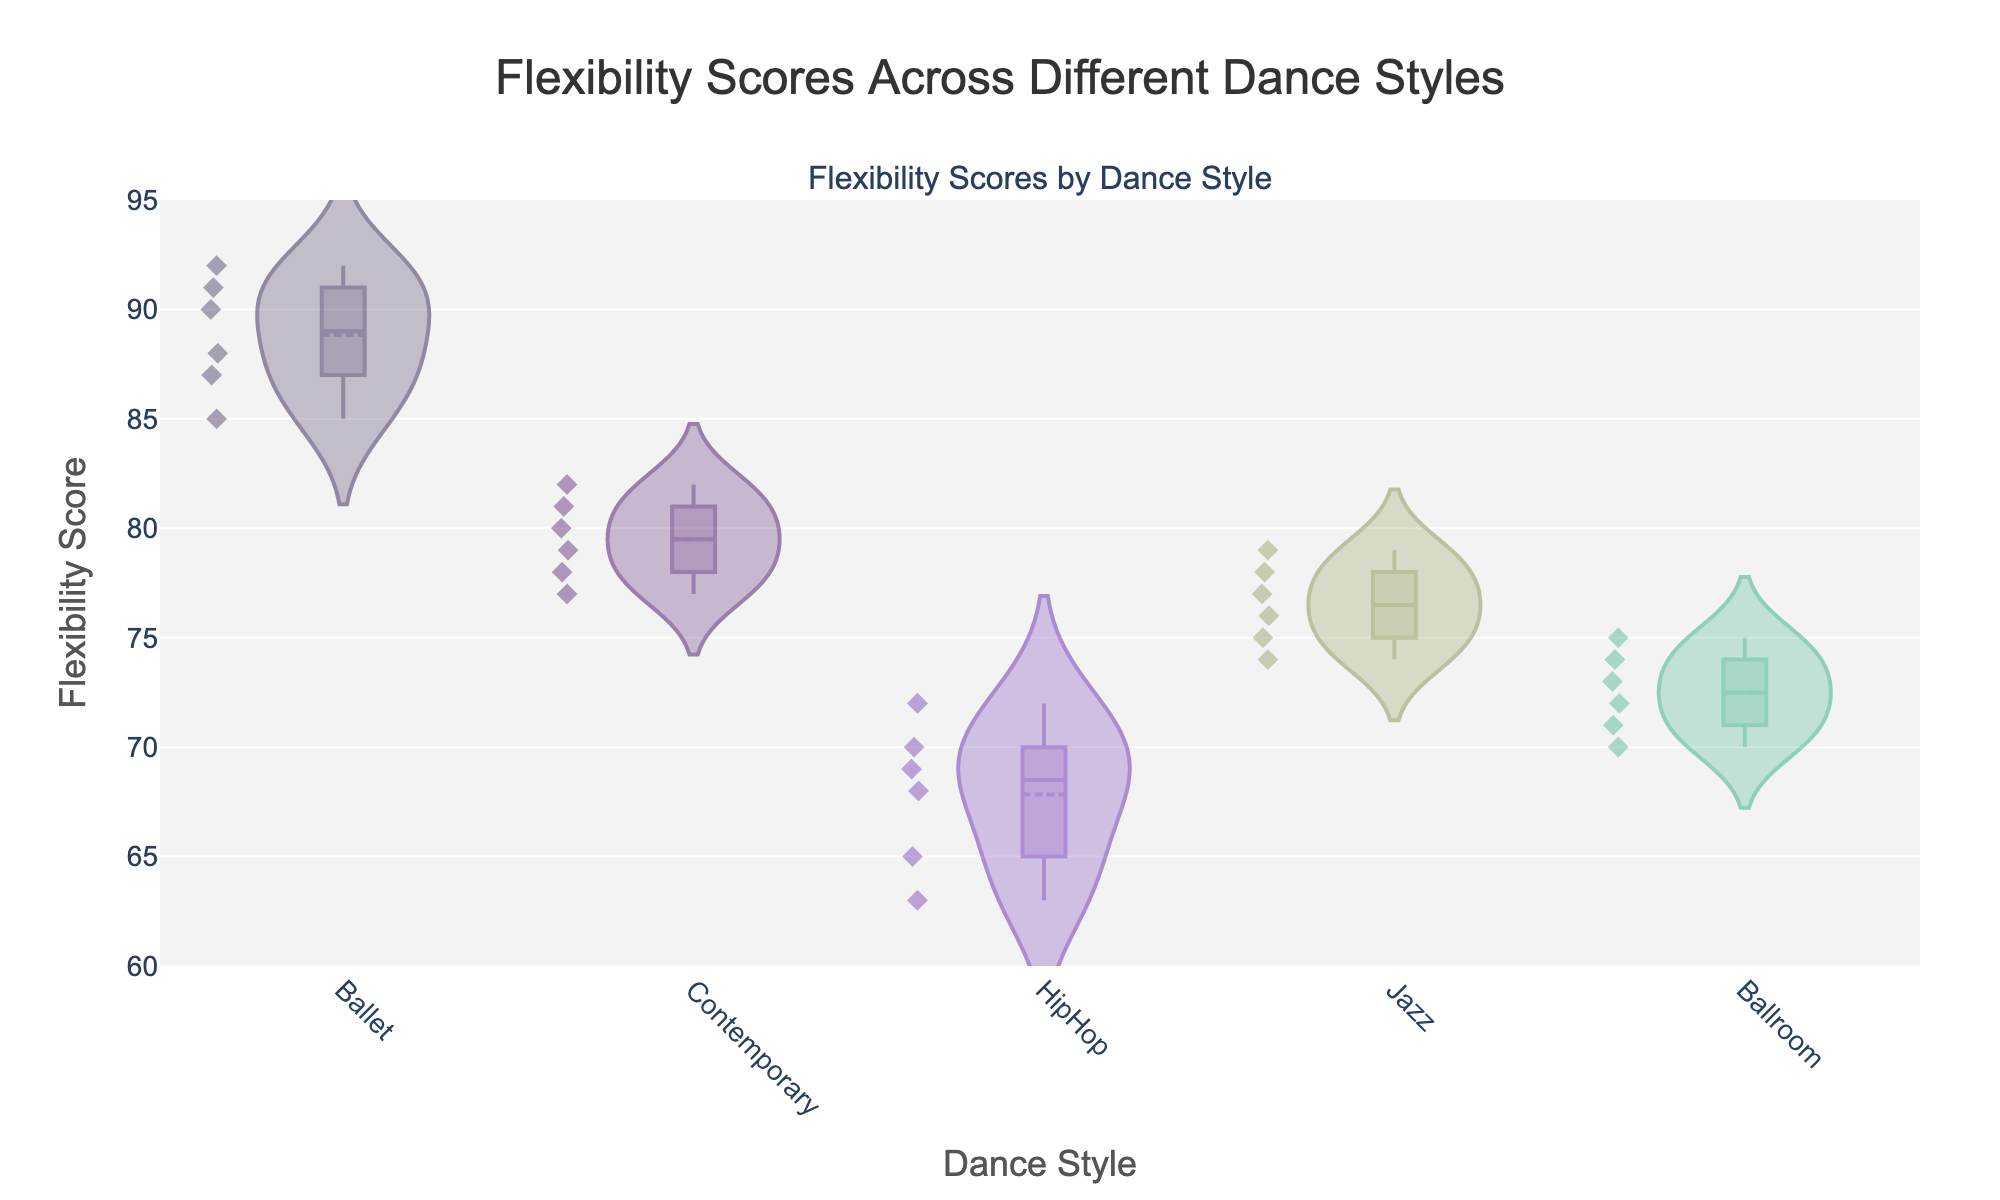What is the title of the figure? The title of the figure is usually located at the top. It provides a summary of the data being visualized.
Answer: Flexibility Scores Across Different Dance Styles Which dance style has the highest median flexibility score? By looking at the central line (median) within each violin plot, Ballet shows the highest median flexibility score.
Answer: Ballet What is the range of the y-axis? The range of the y-axis can be found on the left side of the plot. It starts at 60 and ends at 95.
Answer: 60 to 95 How does the variability in flexibility scores for Contemporary compare to that of HipHop? The spread of the data within the violin plots represents variability. Contemporary has a wider spread, indicating more variability compared to HipHop which has a narrower violin plot.
Answer: Contemporary has more variability What is the mean flexibility score for Jazz? The mean line in Jazz's violin plot indicates the average score. The line inside the Jazz plot appears around 76.
Answer: 76 Which dance style has the largest interquartile range (IQR)? The IQR is represented by the width of the box in the violin plots. Ballet appears to have the largest IQR since its box is significantly wider than the others.
Answer: Ballet Does HipHop or Ballroom have higher flexibility scores on average? By comparing the mean lines in both plots, Ballroom's mean line is slightly higher than that of HipHop.
Answer: Ballroom Which dance style has the most concentrated flexibility scores around its median? Concentration around the median can be inferred from the density and shape of the violin plot. HipHop shows the most concentration as its plot is narrowest with less spread around the median.
Answer: HipHop Are there any outliers in the flexibility scores for Ballet? Outliers would be visible as individual points outside the main violin shape. Ballet does not show separate points indicating no significant outliers.
Answer: No In terms of flexibility, which two dance styles have the most similar distributions? By visually comparing the shapes and spreads of the violin plots, Contemporary and Jazz seem to have the most similar distributions with close ranges and similar medians.
Answer: Contemporary and Jazz 